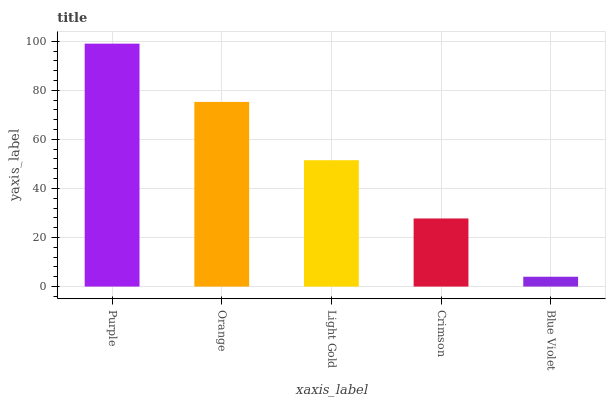Is Orange the minimum?
Answer yes or no. No. Is Orange the maximum?
Answer yes or no. No. Is Purple greater than Orange?
Answer yes or no. Yes. Is Orange less than Purple?
Answer yes or no. Yes. Is Orange greater than Purple?
Answer yes or no. No. Is Purple less than Orange?
Answer yes or no. No. Is Light Gold the high median?
Answer yes or no. Yes. Is Light Gold the low median?
Answer yes or no. Yes. Is Purple the high median?
Answer yes or no. No. Is Orange the low median?
Answer yes or no. No. 